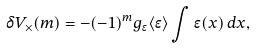<formula> <loc_0><loc_0><loc_500><loc_500>\delta V _ { \times } ( m ) = - ( - 1 ) ^ { m } g _ { \epsilon } \langle \epsilon \rangle \int \epsilon ( x ) \, d x ,</formula> 